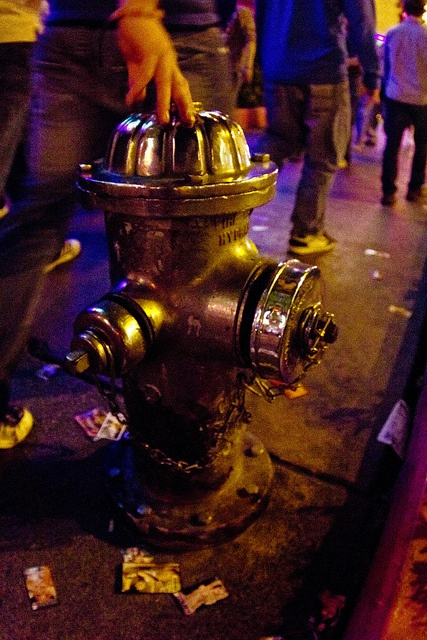Describe the objects in this image and their specific colors. I can see fire hydrant in olive, black, and maroon tones, people in olive, black, maroon, and red tones, people in olive, black, navy, maroon, and purple tones, people in olive, black, purple, and maroon tones, and people in olive, black, and orange tones in this image. 